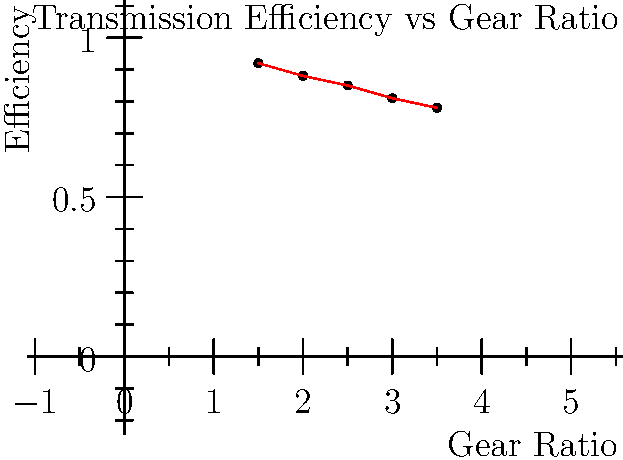In a traditional manual transmission system, higher gear ratios typically result in lower efficiency due to increased friction and mechanical losses. Based on the graph showing the relationship between gear ratio and efficiency for a specific transmission system, what would be the approximate efficiency of a gear with a ratio of 2.75? To determine the approximate efficiency of a gear with a ratio of 2.75, we need to follow these steps:

1. Observe the trend in the graph: As the gear ratio increases, the efficiency decreases.

2. Identify the known data points closest to 2.75:
   - Gear ratio 2.5 has an efficiency of 0.85
   - Gear ratio 3.0 has an efficiency of 0.81

3. Use linear interpolation to estimate the efficiency at 2.75:
   
   Let $x_1 = 2.5$, $y_1 = 0.85$, $x_2 = 3.0$, $y_2 = 0.81$, and $x = 2.75$
   
   The formula for linear interpolation is:
   
   $y = y_1 + \frac{(x - x_1)(y_2 - y_1)}{(x_2 - x_1)}$

4. Plug in the values:
   
   $y = 0.85 + \frac{(2.75 - 2.5)(0.81 - 0.85)}{(3.0 - 2.5)}$
   
   $y = 0.85 + \frac{0.25 * (-0.04)}{0.5}$
   
   $y = 0.85 - 0.02 = 0.83$

5. Round to two decimal places for a reasonable level of precision.

Therefore, the approximate efficiency of a gear with a ratio of 2.75 would be 0.83 or 83%.
Answer: 0.83 (83% efficiency) 